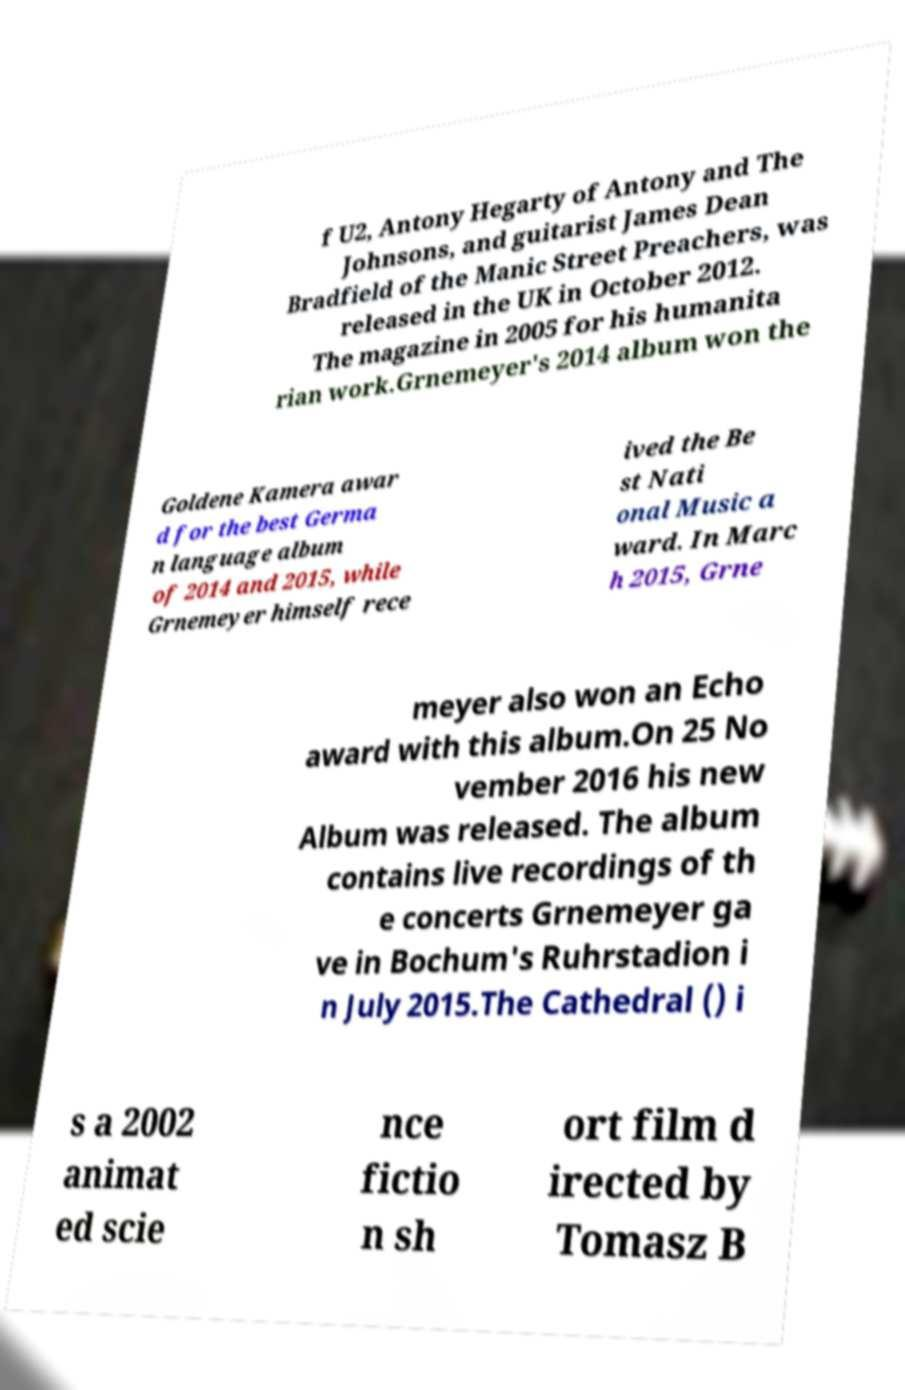Please identify and transcribe the text found in this image. f U2, Antony Hegarty of Antony and The Johnsons, and guitarist James Dean Bradfield of the Manic Street Preachers, was released in the UK in October 2012. The magazine in 2005 for his humanita rian work.Grnemeyer's 2014 album won the Goldene Kamera awar d for the best Germa n language album of 2014 and 2015, while Grnemeyer himself rece ived the Be st Nati onal Music a ward. In Marc h 2015, Grne meyer also won an Echo award with this album.On 25 No vember 2016 his new Album was released. The album contains live recordings of th e concerts Grnemeyer ga ve in Bochum's Ruhrstadion i n July 2015.The Cathedral () i s a 2002 animat ed scie nce fictio n sh ort film d irected by Tomasz B 